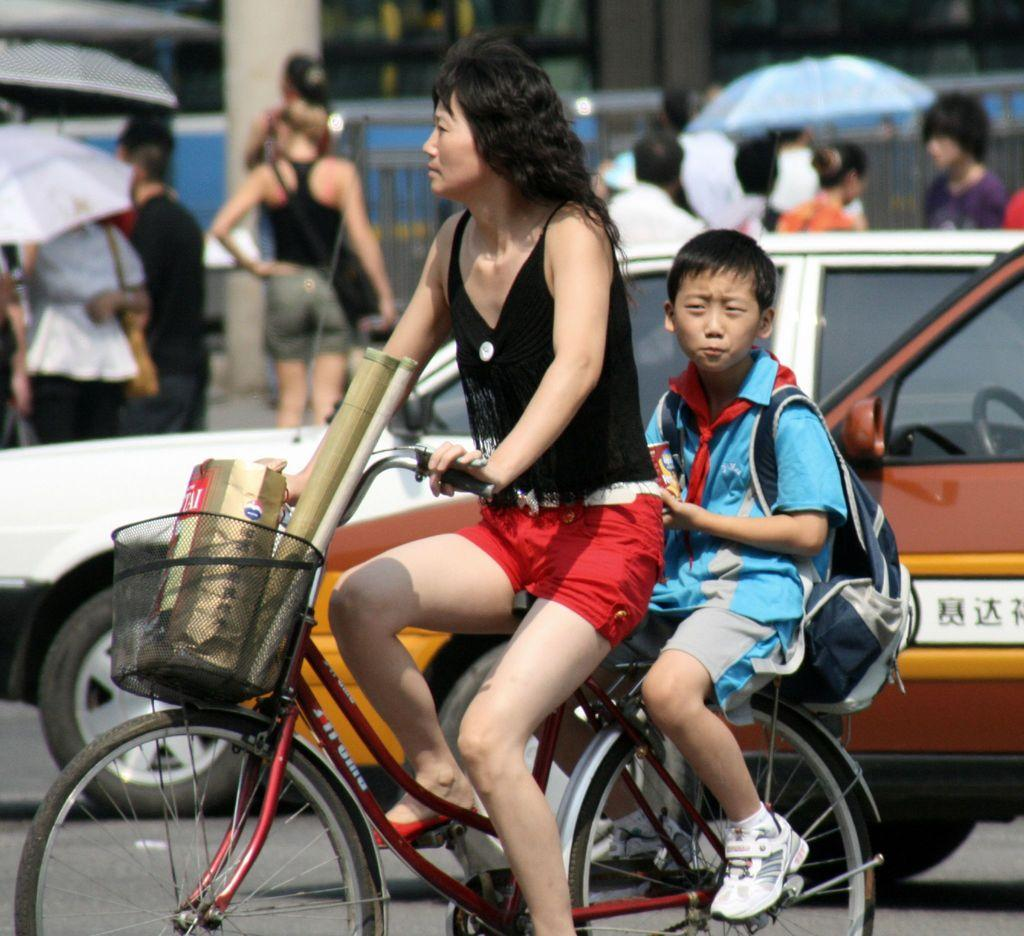How many people are on the bicycle in the image? There are two persons on a bicycle in the image. What else can be seen in the image besides the bicycle? There are vehicles, a road, people, and umbrellas in the image. What type of surface are the people and vehicles traveling on? There is a road in the image. What might be used for protection from the sun or rain in the image? Umbrellas are present in the image for protection from the sun or rain. What type of leaf can be seen growing on the sidewalk in the image? There is no sidewalk or leaf present in the image. What type of berry is being used as a decoration on the bicycle in the image? There are no berries present in the image, and the bicycle is not decorated with any berries. 